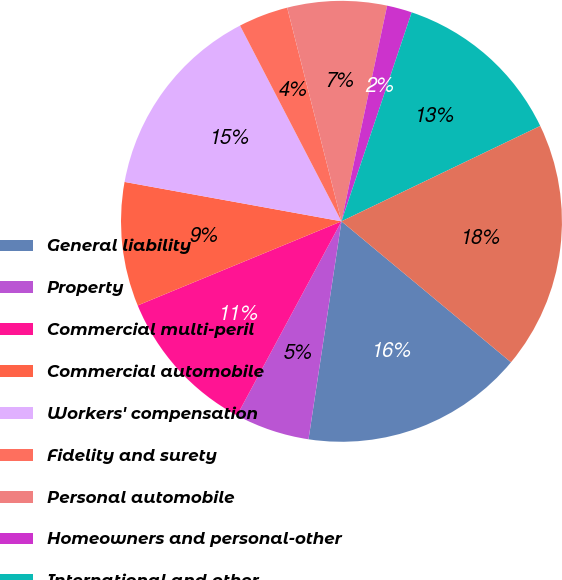Convert chart. <chart><loc_0><loc_0><loc_500><loc_500><pie_chart><fcel>General liability<fcel>Property<fcel>Commercial multi-peril<fcel>Commercial automobile<fcel>Workers' compensation<fcel>Fidelity and surety<fcel>Personal automobile<fcel>Homeowners and personal-other<fcel>International and other<fcel>Property-casualty<nl><fcel>16.35%<fcel>5.47%<fcel>10.91%<fcel>9.09%<fcel>14.53%<fcel>3.65%<fcel>7.28%<fcel>1.84%<fcel>12.72%<fcel>18.16%<nl></chart> 